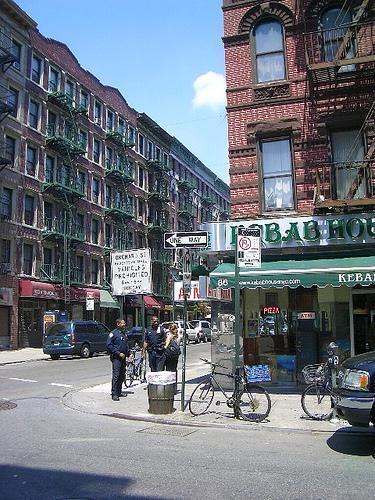How many people can be seen?
Give a very brief answer. 3. How many men can be seen?
Give a very brief answer. 2. How many cars are there?
Give a very brief answer. 2. 